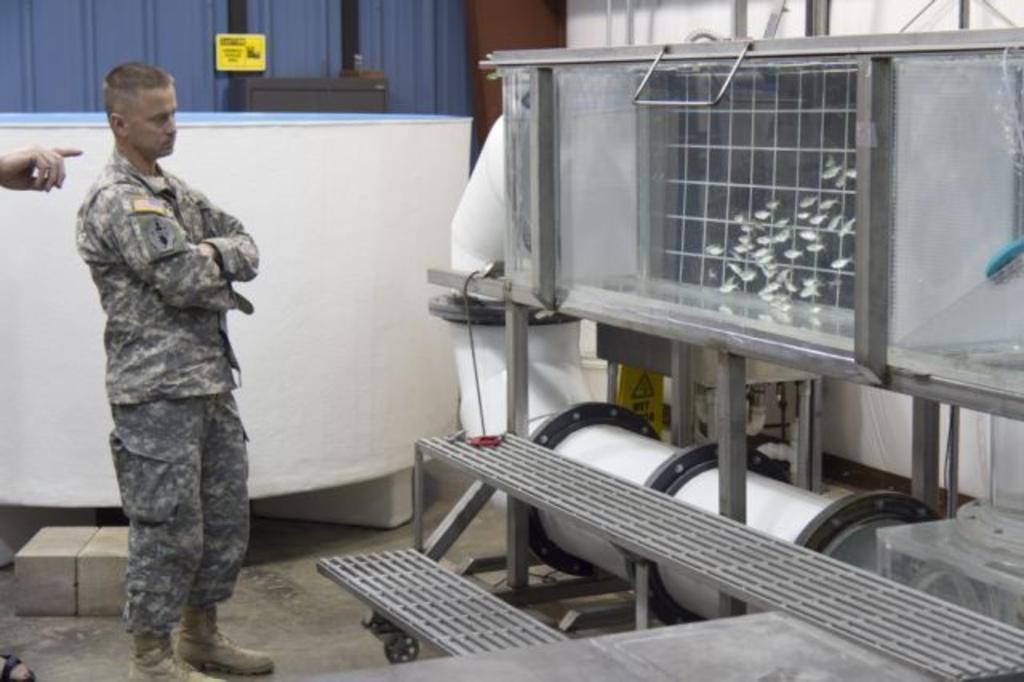Please provide a concise description of this image. In this image there is an army personnel standing and is looking at an equipment in front of him, behind the person there is a person's hand and foot, beside the army personnel there is an object, in the background of the image there is a wall, on the floor there are two bricks. 